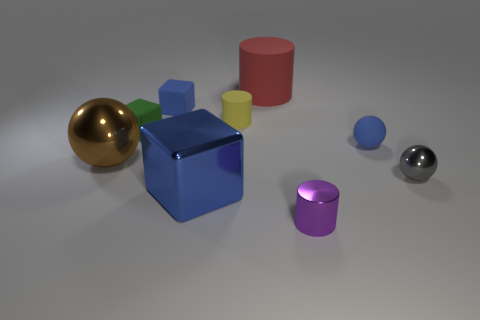Subtract all small rubber blocks. How many blocks are left? 1 Subtract all blue balls. How many balls are left? 2 Subtract all balls. How many objects are left? 6 Subtract 3 cylinders. How many cylinders are left? 0 Subtract all blue balls. Subtract all red cylinders. How many balls are left? 2 Subtract all red blocks. How many purple balls are left? 0 Subtract all big red matte objects. Subtract all big shiny things. How many objects are left? 6 Add 3 gray balls. How many gray balls are left? 4 Add 3 purple cubes. How many purple cubes exist? 3 Subtract 0 red blocks. How many objects are left? 9 